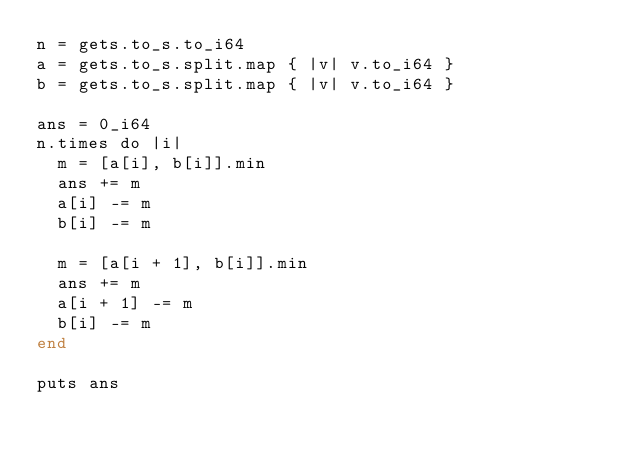<code> <loc_0><loc_0><loc_500><loc_500><_Crystal_>n = gets.to_s.to_i64
a = gets.to_s.split.map { |v| v.to_i64 }
b = gets.to_s.split.map { |v| v.to_i64 }

ans = 0_i64
n.times do |i|
  m = [a[i], b[i]].min
  ans += m
  a[i] -= m
  b[i] -= m

  m = [a[i + 1], b[i]].min
  ans += m
  a[i + 1] -= m
  b[i] -= m
end

puts ans
</code> 